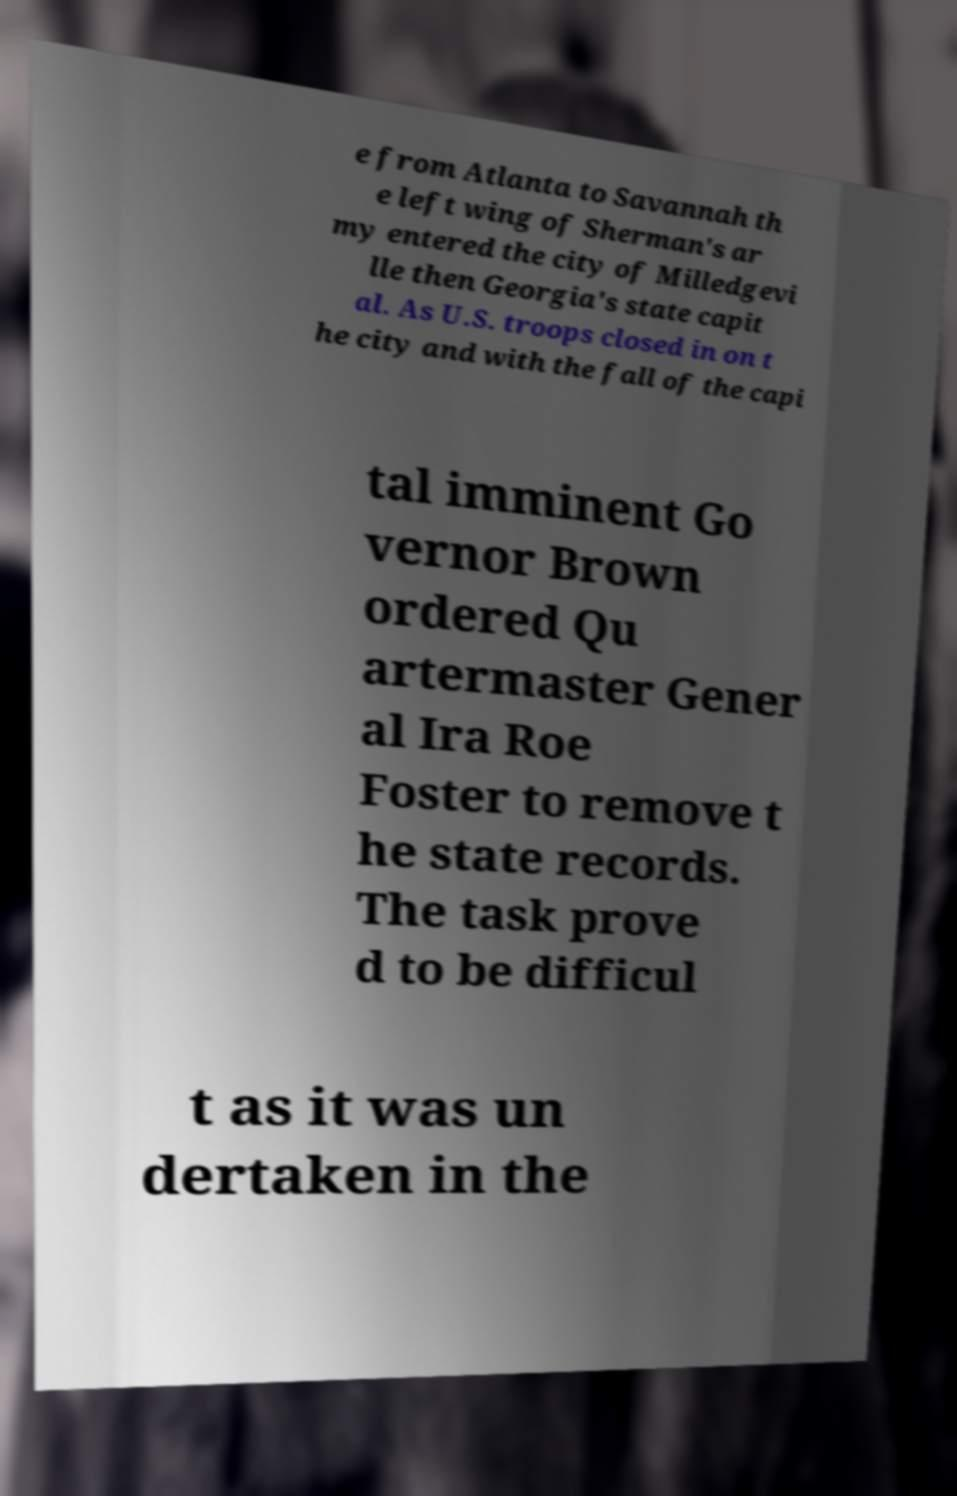Please read and relay the text visible in this image. What does it say? e from Atlanta to Savannah th e left wing of Sherman's ar my entered the city of Milledgevi lle then Georgia's state capit al. As U.S. troops closed in on t he city and with the fall of the capi tal imminent Go vernor Brown ordered Qu artermaster Gener al Ira Roe Foster to remove t he state records. The task prove d to be difficul t as it was un dertaken in the 